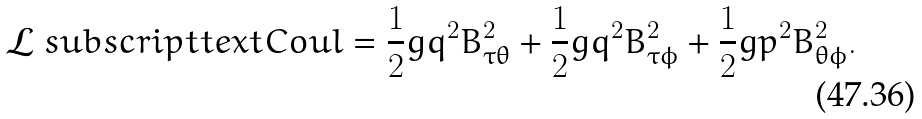Convert formula to latex. <formula><loc_0><loc_0><loc_500><loc_500>\mathcal { L } _ { \ } s u b s c r i p t t e x t { C o u l } = \frac { 1 } { 2 } g q ^ { 2 } B _ { \tau \theta } ^ { 2 } + \frac { 1 } { 2 } g q ^ { 2 } B _ { \tau \phi } ^ { 2 } + \frac { 1 } { 2 } g p ^ { 2 } B _ { \theta \phi } ^ { 2 } .</formula> 